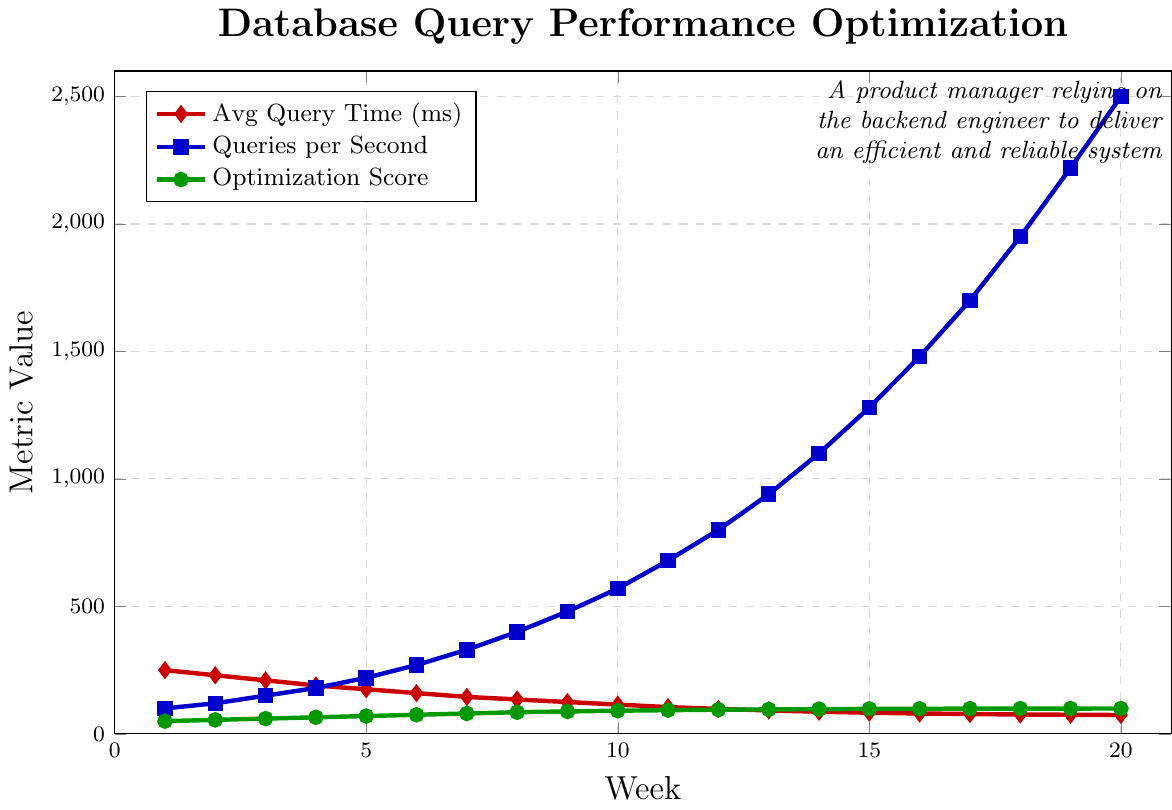What is the trend of Average Query Time over the 20 weeks? To determine the trend, observe the red line plot representing Average Query Time. It generally shows a decreasing pattern over the weeks, starting from 250 ms in week 1 and reducing to 74 ms by week 20.
Answer: Decreasing By how much did the Queries per Second increase between week 10 and week 20? Check the values of the blue line plot for Queries per Second at week 10 and week 20. At week 10, it is 570, and at week 20, it is 2500. The increase is 2500 - 570 = 1930 queries per second.
Answer: 1930 What week marks the first instance where the Optimization Score is at least 95? Look at the green line plot for Optimization Score and locate where it first reaches or exceeds 95. This occurs at week 12 with a score of 95.
Answer: Week 12 Compare the slope steepness between the first 5 and the last 5 weeks for Average Query Time. Which period has a steeper decline? In the first 5 weeks, the decline is from 250 ms to 175 ms, a total change of 75 ms. In the last 5 weeks, the decline is from 80 ms to 74 ms, a change of 6 ms. The steeper decline is in the first 5 weeks.
Answer: First 5 weeks What is the average Optimization Score from week 15 to week 20? Sum the Optimization Scores from week 15 to week 20 and divide by the number of weeks. The scores are 98, 98.5, 99, 99.2, 99.4, and 99.5. The sum is 593.6. The number of weeks is 6. So, 593.6 / 6 = 98.933
Answer: 98.933 Which week has the lowest Average Query Time? Find the lowest point on the red line plot for Average Query Time and note the corresponding week. The lowest point is 74 ms at week 20.
Answer: Week 20 Is there any week where all three metrics have shown improvement compared to the previous week? Check each week's data for all three metrics: Average Query Time should decrease, Queries per Second and Optimization Score should both increase. For example, from week 10 to week 11, Average Query Time decreases from 115 to 105 ms, Queries per Second increases from 570 to 680, and Optimization Score increases from 91 to 93, indicating improvement in all three metrics.
Answer: Week 11 Between which weeks does Queries per Second see the highest rate of increase? Calculate the difference in Queries per Second between consecutive weeks and identify the highest difference. From week 7 to week 8, it increases from 330 to 400 (70). From week 8 to week 9, it increases from 400 to 480 (80), which is higher than the rest but not the highest. The highest rate is from week 19 to week 20, increasing from 2220 to 2500 (280), which is the highest increase observed.
Answer: Week 19 to Week 20 